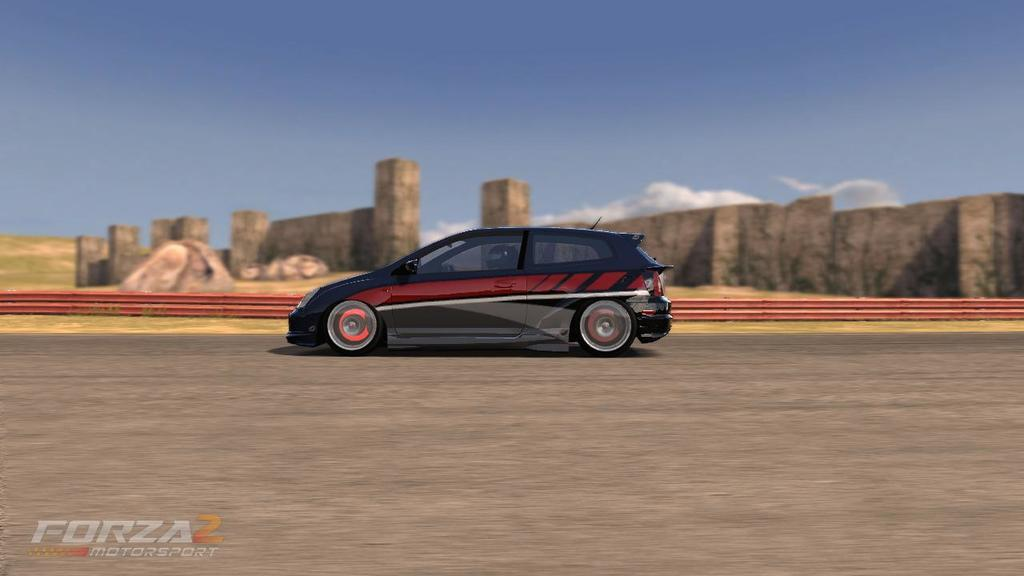What is the main subject of the image? There is a car on the road in the image. What can be seen in the background of the image? There is a wall and clouds visible in the background of the image. What type of jam is being spread on the passenger's sandwich in the image? There is no sandwich or jam present in the image; it only features a car on the road with a wall and clouds in the background. 